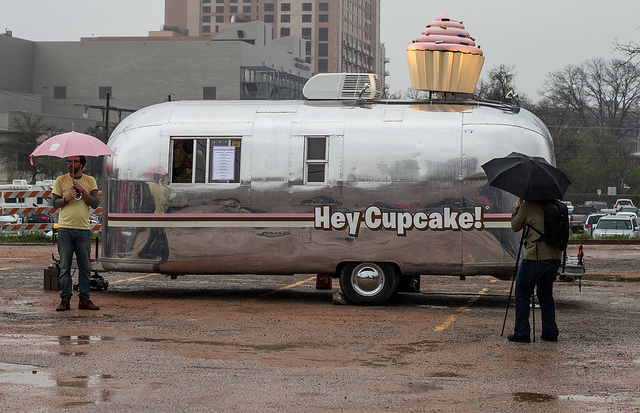Identify the text displayed in this image. Hey Cupcake 